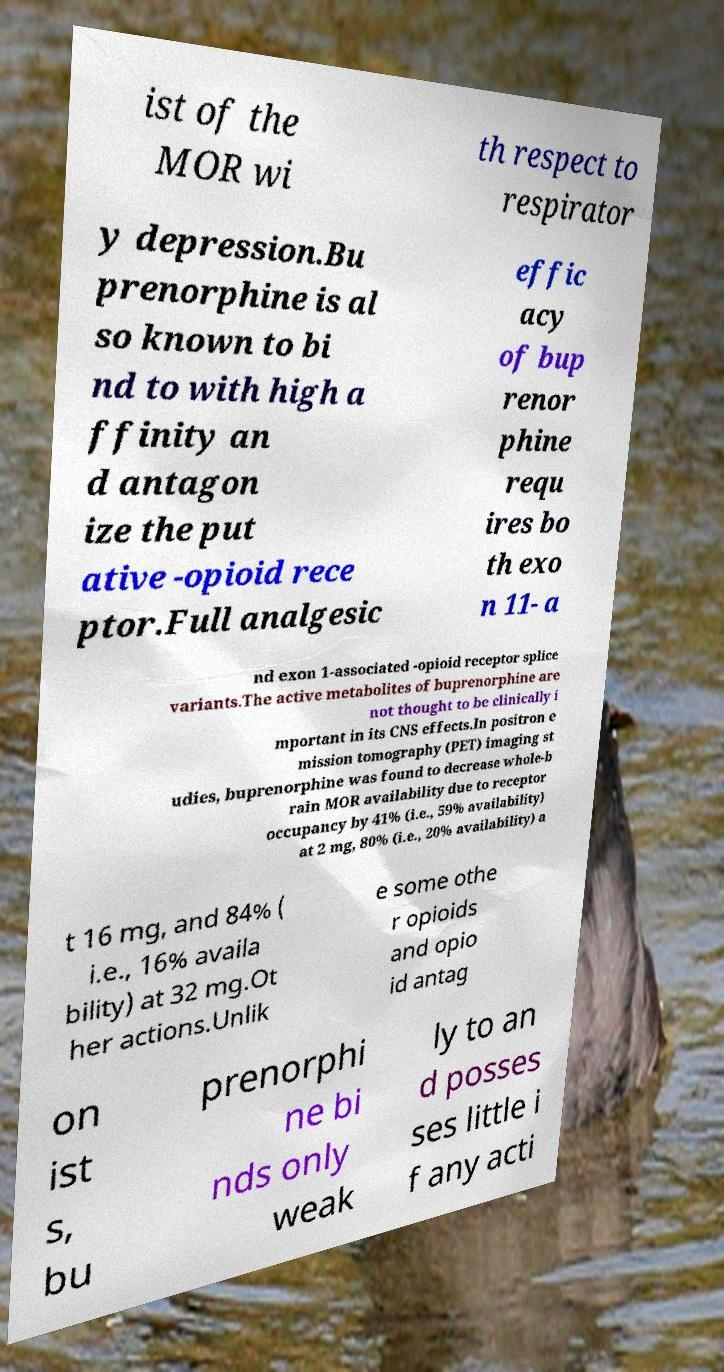Please identify and transcribe the text found in this image. ist of the MOR wi th respect to respirator y depression.Bu prenorphine is al so known to bi nd to with high a ffinity an d antagon ize the put ative -opioid rece ptor.Full analgesic effic acy of bup renor phine requ ires bo th exo n 11- a nd exon 1-associated -opioid receptor splice variants.The active metabolites of buprenorphine are not thought to be clinically i mportant in its CNS effects.In positron e mission tomography (PET) imaging st udies, buprenorphine was found to decrease whole-b rain MOR availability due to receptor occupancy by 41% (i.e., 59% availability) at 2 mg, 80% (i.e., 20% availability) a t 16 mg, and 84% ( i.e., 16% availa bility) at 32 mg.Ot her actions.Unlik e some othe r opioids and opio id antag on ist s, bu prenorphi ne bi nds only weak ly to an d posses ses little i f any acti 